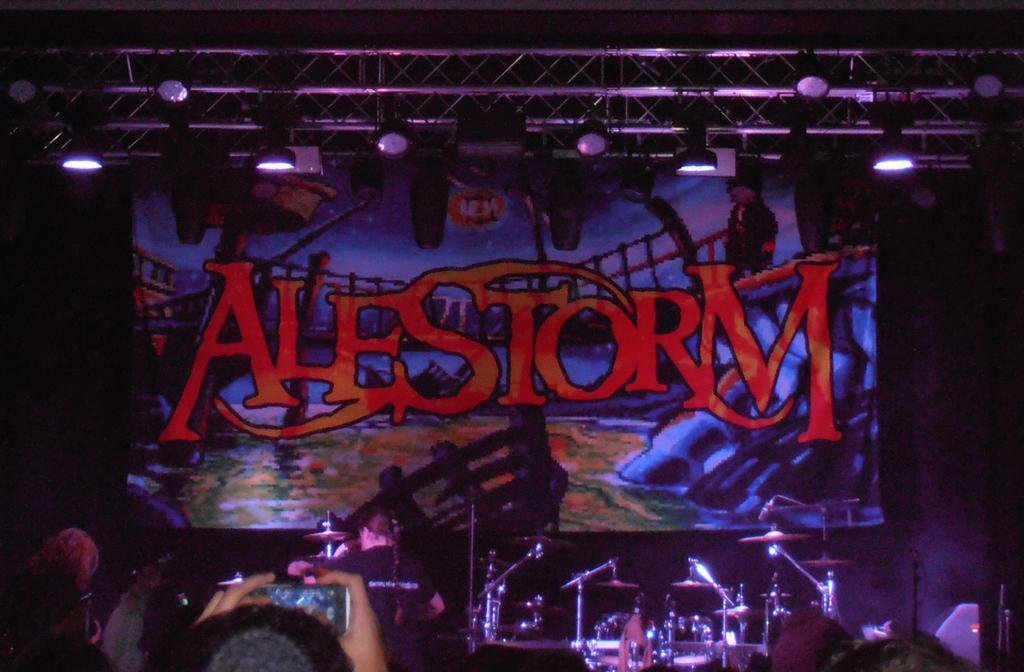How would you summarize this image in a sentence or two? There is a poster with something written on that. On the stage there are musical instrument. In the front we can see a person holding a mobile. On the top there are stands with lights. 